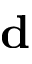Convert formula to latex. <formula><loc_0><loc_0><loc_500><loc_500>d</formula> 